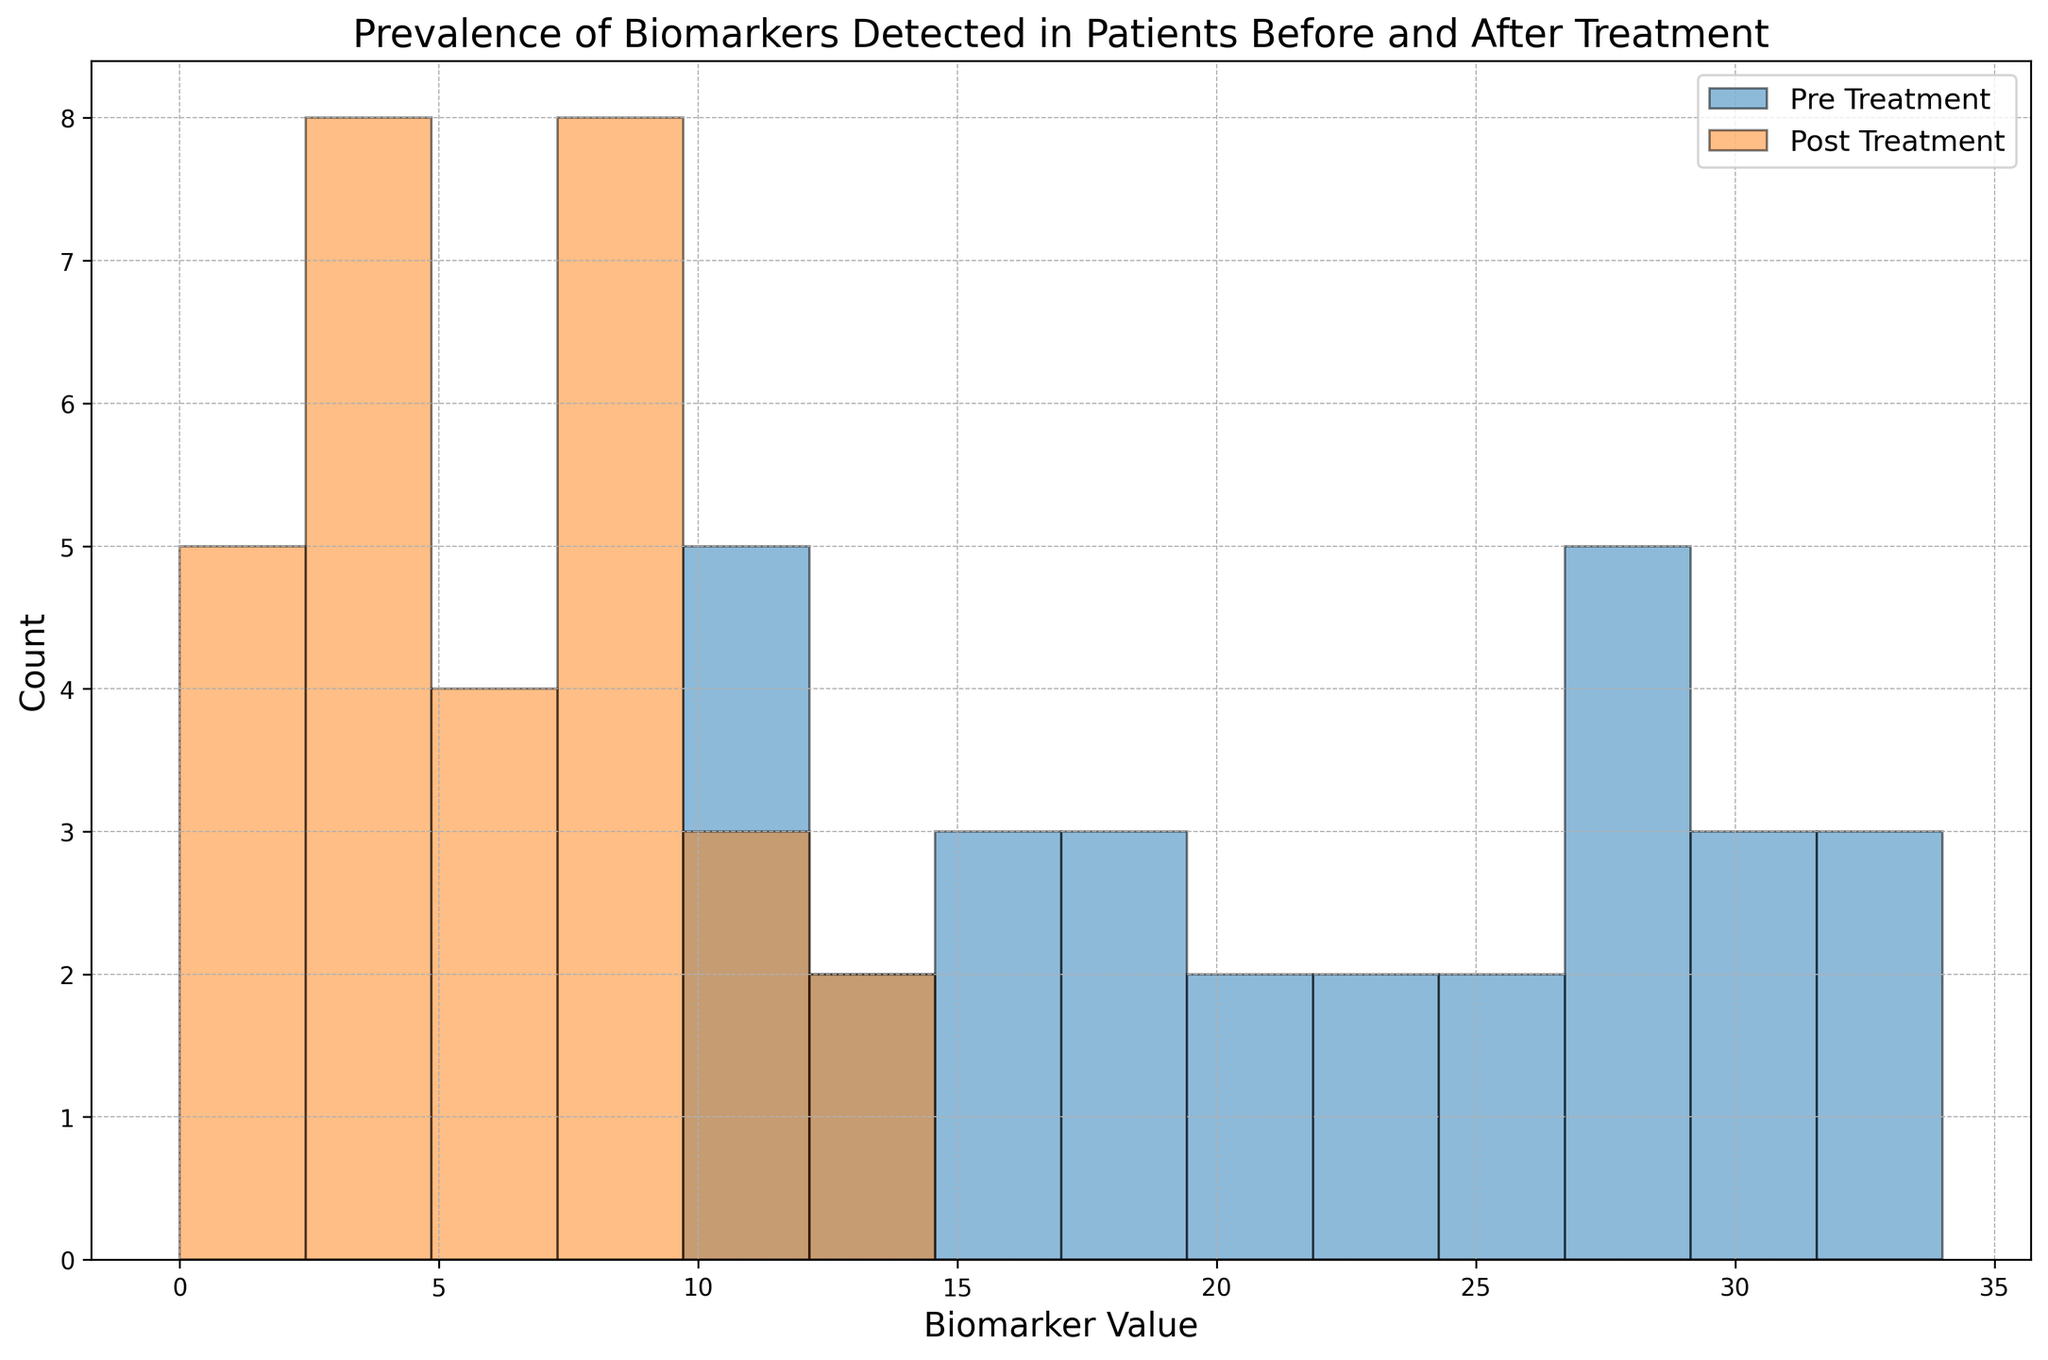what does the histogram compare? The histogram compares the prevalence of biomarkers detected in patients before and after nanobiotechnology treatment. The "Pre Treatment" data is shown in blue, and the "Post Treatment" data is shown in orange.
Answer: Biomarker prevalence pre- and post-treatment Which color represents the pre-treatment data in the histogram? In the histogram, the color blue is used to represent the pre-treatment data.
Answer: Blue Which treatment phase shows a higher peak value in the histogram? The pre-treatment phase (blue bars) shows a higher peak value compared to the post-treatment phase (orange bars).
Answer: Pre-treatment How many bins are used in the histogram? The histogram uses bins to group the data, and by counting the visible divisions on the x-axis, we can determine there are 14 bins used.
Answer: 14 What is the approximate maximum count for any bin in the pre-treatment data? By observing the height of the highest blue bar, it represents a count of around 6 (full height of the highest bar).
Answer: 6 Which biomarker value range shows the most significant reduction in count after treatment? By visually comparing the heights of the bars, the range of 18-24 shows a prominent reduction in height going from pre-treatment (blue) to post-treatment (orange).
Answer: 18-24 Is there any range where the post-treatment count is higher than the pre-treatment count? By comparing the heights of the orange and blue bars, we can see that the post-treatment count is never higher than the pre-treatment count in any bin range.
Answer: No What can be concluded about the efficacy of the nanobiotechnology treatment based on the histogram? The histogram shows a significant reduction in the biomarker prevalence in patients after the treatment, as indicated by lower heights of the orange bars across all ranges compared to the blue bars. This suggests the treatment is effective.
Answer: Reduced prevalence post-treatment What is the sum of the counts of the pre-treatment and post-treatment bins in the 24-30 range? To find this, we sum the heights of blue (pre-treatment) bars and orange (post-treatment) bars in the 24-30 range. From the histogram, pre-treatment count is around 10 (3+3+4) and post-treatment count is around 5 (2+2+1). So, 10 + 5 = 15.
Answer: 15 How would you describe the overall trend in biomarker values before and after treatment? The overall trend shows that biomarker values are consistently lower after the nanobiotechnology treatment, indicated by the shorter orange bars compared to the blue bars across nearly all ranges.
Answer: Consistently lower post-treatment 